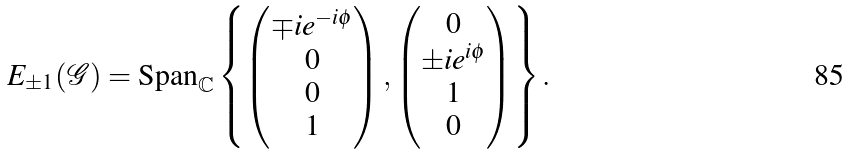<formula> <loc_0><loc_0><loc_500><loc_500>E _ { \pm 1 } ( \mathcal { G } ) = \text {Span} _ { \mathbb { C } } \left \{ \begin{pmatrix} \mp i e ^ { - i \phi } \\ 0 \\ 0 \\ 1 \end{pmatrix} , \begin{pmatrix} 0 \\ \pm i e ^ { i \phi } \\ 1 \\ 0 \end{pmatrix} \right \} .</formula> 